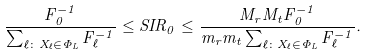Convert formula to latex. <formula><loc_0><loc_0><loc_500><loc_500>\frac { F _ { 0 } ^ { - 1 } } { \sum _ { \ell \colon X _ { \ell } \in \Phi _ { L } } F _ { \ell } ^ { - 1 } } \leq S I R _ { 0 } \leq \frac { M _ { r } M _ { t } F _ { 0 } ^ { - 1 } } { m _ { r } m _ { t } \sum _ { \ell \colon X _ { \ell } \in \Phi _ { L } } F _ { \ell } ^ { - 1 } } .</formula> 